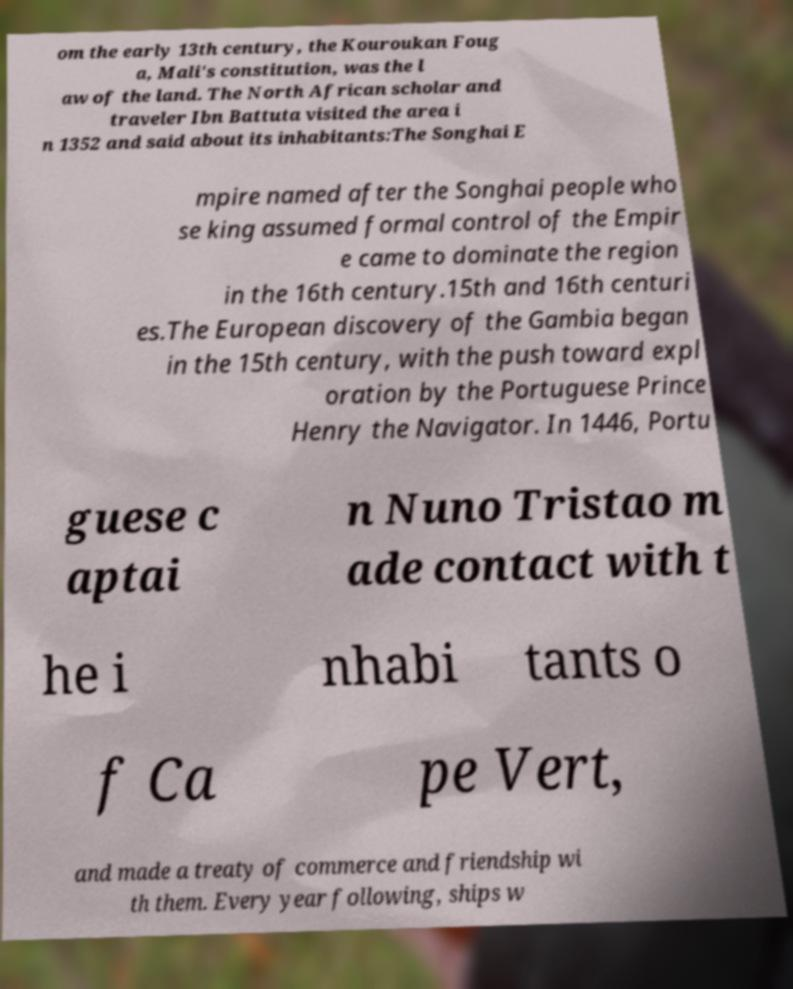Please read and relay the text visible in this image. What does it say? om the early 13th century, the Kouroukan Foug a, Mali's constitution, was the l aw of the land. The North African scholar and traveler Ibn Battuta visited the area i n 1352 and said about its inhabitants:The Songhai E mpire named after the Songhai people who se king assumed formal control of the Empir e came to dominate the region in the 16th century.15th and 16th centuri es.The European discovery of the Gambia began in the 15th century, with the push toward expl oration by the Portuguese Prince Henry the Navigator. In 1446, Portu guese c aptai n Nuno Tristao m ade contact with t he i nhabi tants o f Ca pe Vert, and made a treaty of commerce and friendship wi th them. Every year following, ships w 